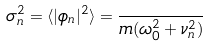<formula> <loc_0><loc_0><loc_500><loc_500>\sigma _ { n } ^ { 2 } = \langle | \phi _ { n } | ^ { 2 } \rangle = \frac { } { m ( \omega _ { 0 } ^ { 2 } + \nu _ { n } ^ { 2 } ) }</formula> 